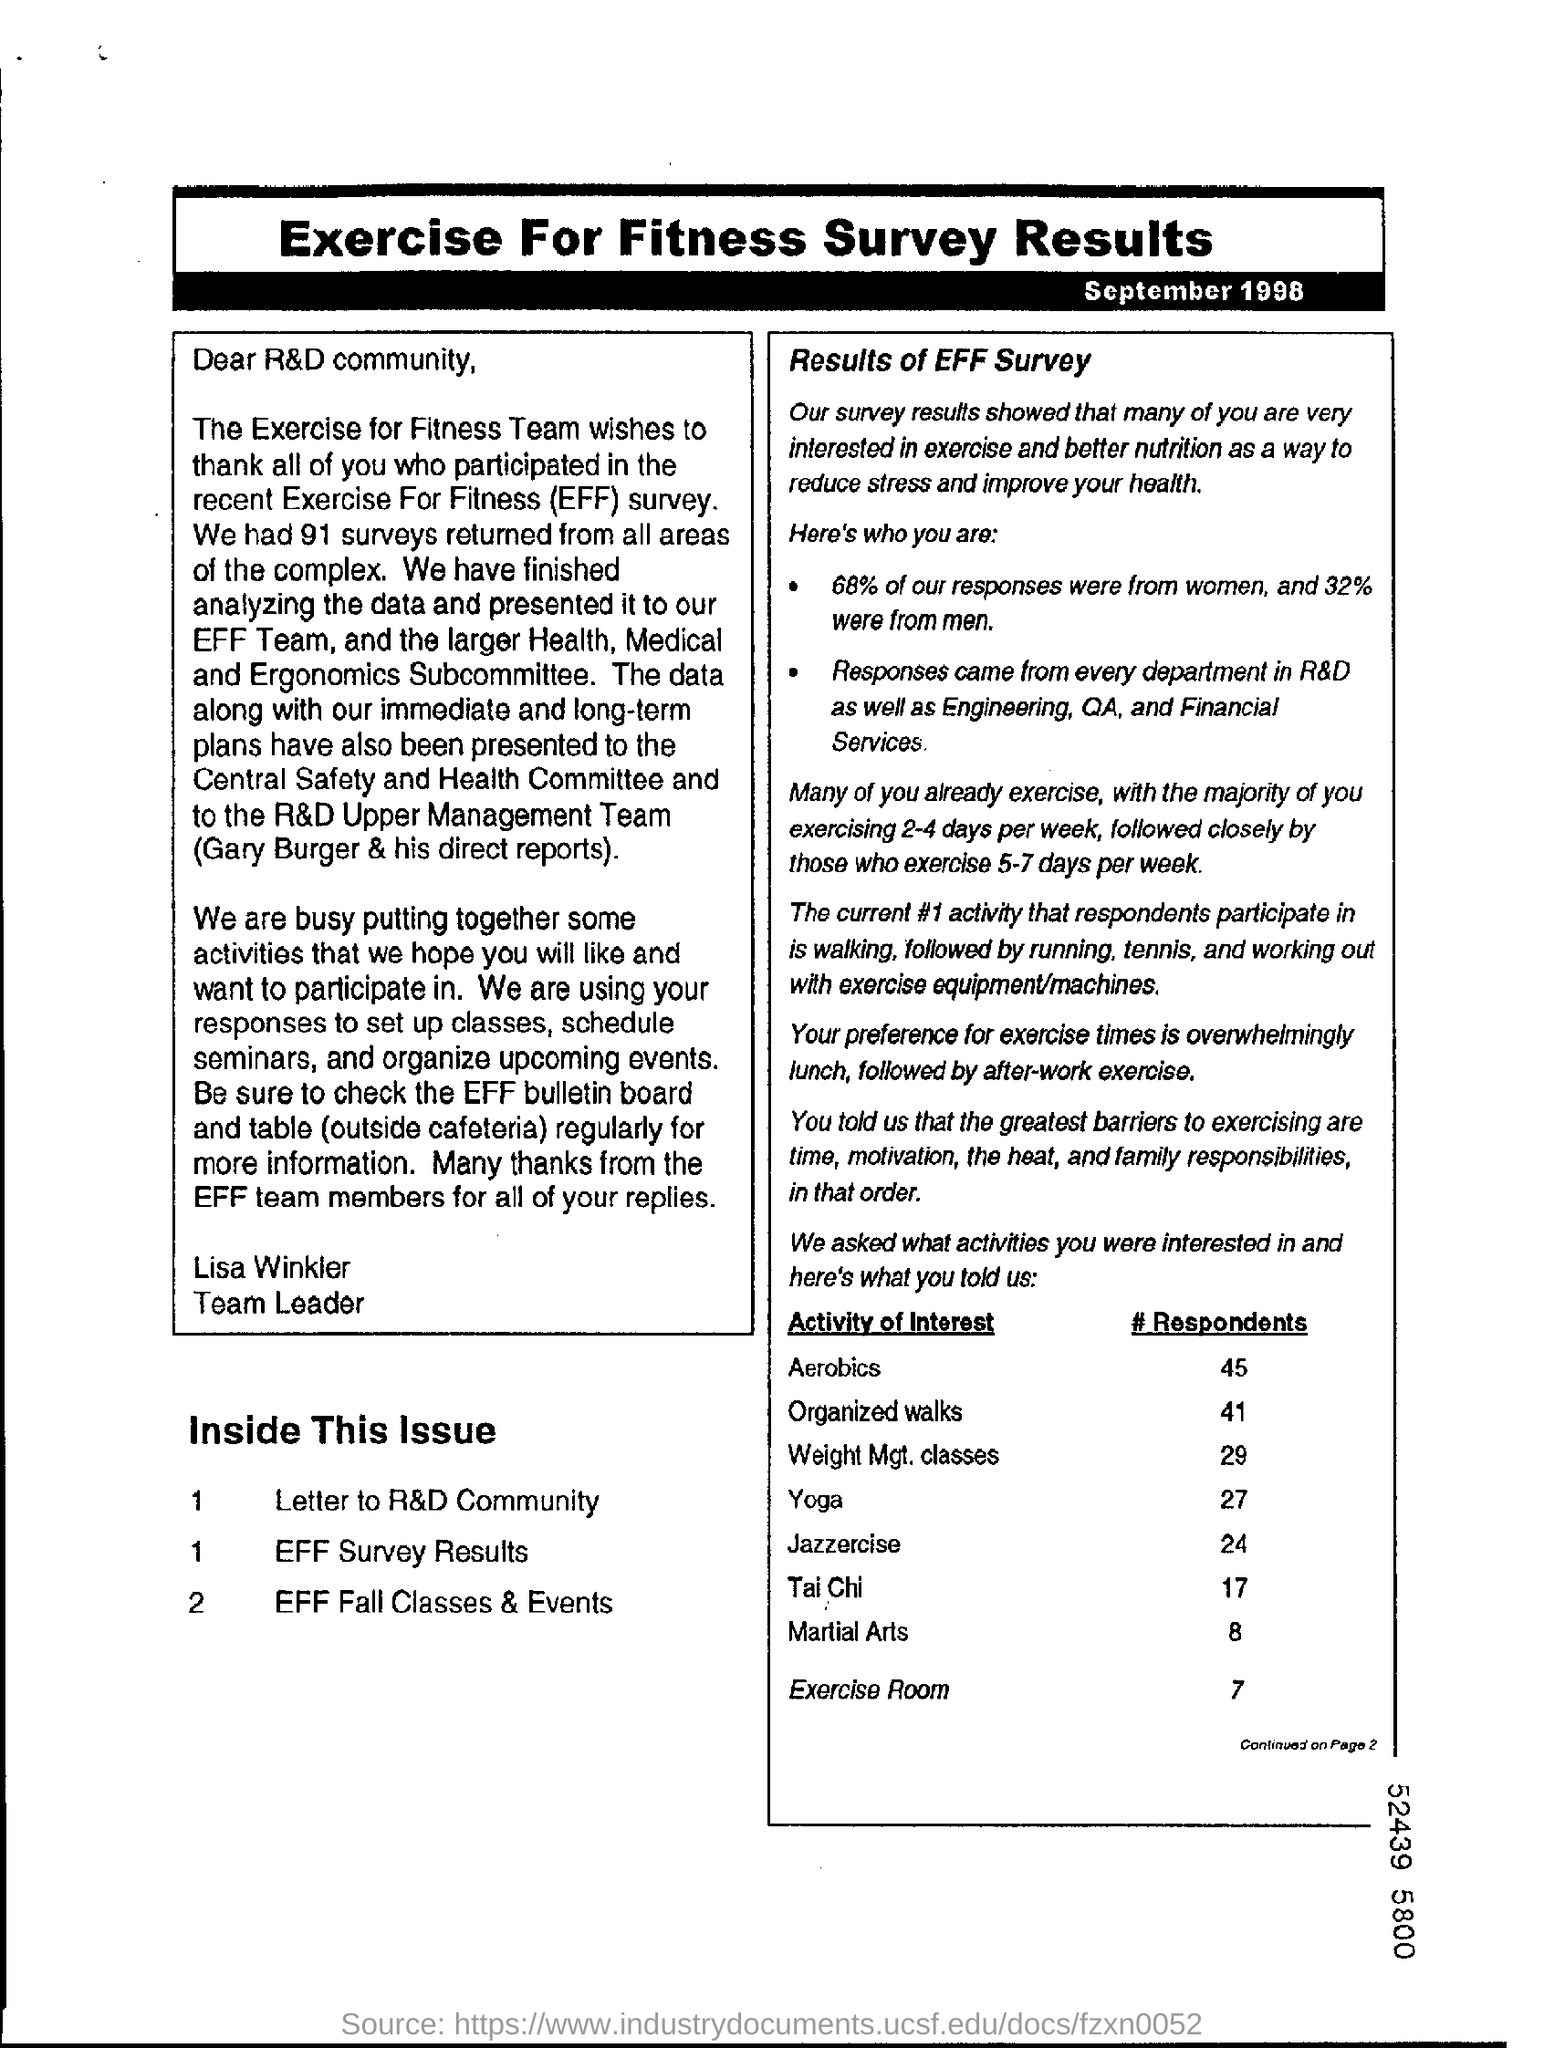What is the  % of response got from women
Offer a terse response. 68%. What were the % of response got from men
Your answer should be compact. 32%. 